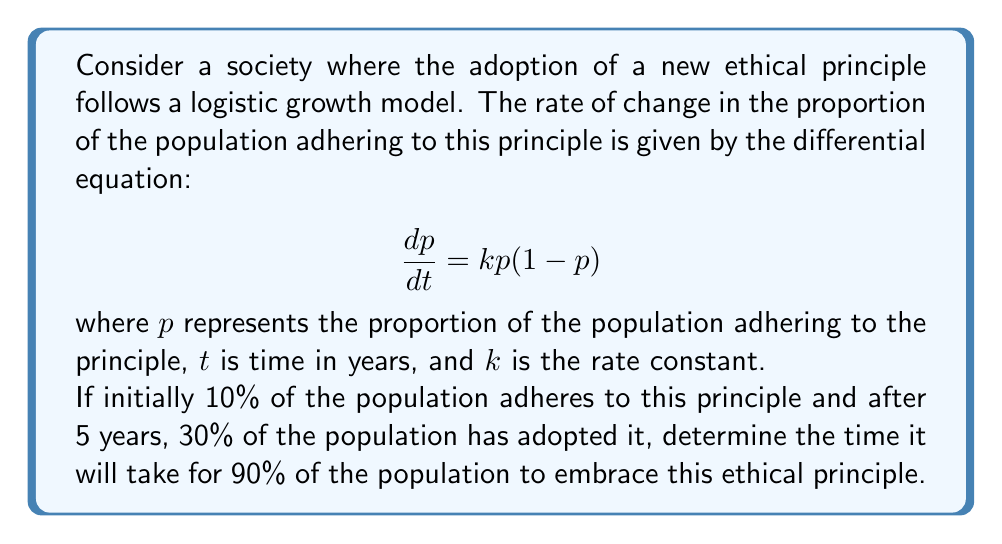Solve this math problem. To solve this problem, we'll follow these steps:

1) First, we need to find the value of $k$ using the given information.

2) The solution to the logistic differential equation is:

   $$p(t) = \frac{p_0}{p_0 + (1-p_0)e^{-kt}}$$

   where $p_0$ is the initial proportion.

3) We know that $p_0 = 0.1$ and $p(5) = 0.3$. Let's substitute these into the equation:

   $$0.3 = \frac{0.1}{0.1 + (1-0.1)e^{-5k}}$$

4) Solving this equation for $k$:

   $$0.3(0.1 + 0.9e^{-5k}) = 0.1$$
   $$0.03 + 0.27e^{-5k} = 0.1$$
   $$0.27e^{-5k} = 0.07$$
   $$e^{-5k} = \frac{0.07}{0.27} \approx 0.2593$$
   $$-5k = \ln(0.2593)$$
   $$k = -\frac{1}{5}\ln(0.2593) \approx 0.2706$$

5) Now that we have $k$, we can find the time $t$ when $p(t) = 0.9$:

   $$0.9 = \frac{0.1}{0.1 + (1-0.1)e^{-0.2706t}}$$

6) Solving this equation for $t$:

   $$0.9(0.1 + 0.9e^{-0.2706t}) = 0.1$$
   $$0.09 + 0.81e^{-0.2706t} = 0.1$$
   $$0.81e^{-0.2706t} = 0.01$$
   $$e^{-0.2706t} = \frac{0.01}{0.81} \approx 0.0123$$
   $$-0.2706t = \ln(0.0123)$$
   $$t = -\frac{1}{0.2706}\ln(0.0123) \approx 15.76$$

Therefore, it will take approximately 15.76 years for 90% of the population to embrace this ethical principle.
Answer: It will take approximately 15.76 years for 90% of the population to adopt the new ethical principle. 